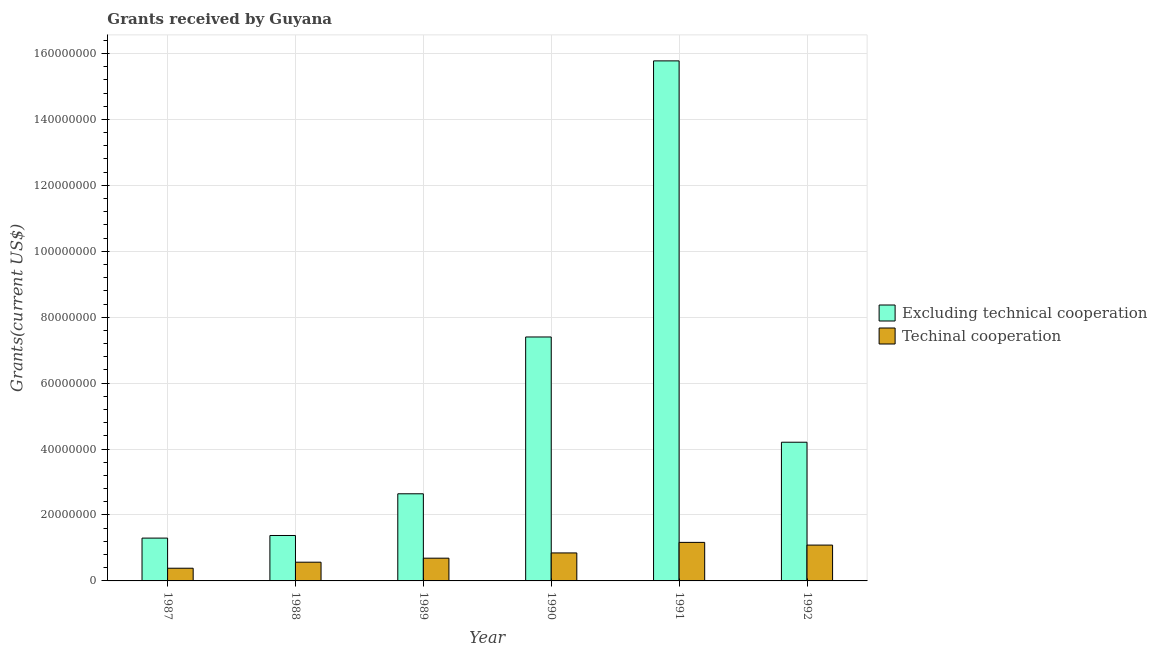How many different coloured bars are there?
Your response must be concise. 2. How many groups of bars are there?
Ensure brevity in your answer.  6. Are the number of bars per tick equal to the number of legend labels?
Offer a terse response. Yes. Are the number of bars on each tick of the X-axis equal?
Give a very brief answer. Yes. In how many cases, is the number of bars for a given year not equal to the number of legend labels?
Ensure brevity in your answer.  0. What is the amount of grants received(excluding technical cooperation) in 1992?
Provide a succinct answer. 4.21e+07. Across all years, what is the maximum amount of grants received(excluding technical cooperation)?
Offer a very short reply. 1.58e+08. Across all years, what is the minimum amount of grants received(excluding technical cooperation)?
Your answer should be compact. 1.30e+07. In which year was the amount of grants received(including technical cooperation) maximum?
Keep it short and to the point. 1991. What is the total amount of grants received(including technical cooperation) in the graph?
Ensure brevity in your answer.  4.75e+07. What is the difference between the amount of grants received(excluding technical cooperation) in 1987 and that in 1990?
Keep it short and to the point. -6.10e+07. What is the difference between the amount of grants received(excluding technical cooperation) in 1990 and the amount of grants received(including technical cooperation) in 1988?
Offer a terse response. 6.02e+07. What is the average amount of grants received(including technical cooperation) per year?
Make the answer very short. 7.91e+06. What is the ratio of the amount of grants received(including technical cooperation) in 1987 to that in 1990?
Your answer should be compact. 0.45. Is the amount of grants received(excluding technical cooperation) in 1988 less than that in 1992?
Keep it short and to the point. Yes. Is the difference between the amount of grants received(excluding technical cooperation) in 1987 and 1991 greater than the difference between the amount of grants received(including technical cooperation) in 1987 and 1991?
Offer a terse response. No. What is the difference between the highest and the second highest amount of grants received(including technical cooperation)?
Your answer should be compact. 8.20e+05. What is the difference between the highest and the lowest amount of grants received(including technical cooperation)?
Your answer should be compact. 7.84e+06. In how many years, is the amount of grants received(excluding technical cooperation) greater than the average amount of grants received(excluding technical cooperation) taken over all years?
Your answer should be compact. 2. Is the sum of the amount of grants received(excluding technical cooperation) in 1990 and 1992 greater than the maximum amount of grants received(including technical cooperation) across all years?
Make the answer very short. No. What does the 1st bar from the left in 1988 represents?
Your answer should be compact. Excluding technical cooperation. What does the 1st bar from the right in 1988 represents?
Provide a short and direct response. Techinal cooperation. Are all the bars in the graph horizontal?
Give a very brief answer. No. What is the difference between two consecutive major ticks on the Y-axis?
Offer a terse response. 2.00e+07. How many legend labels are there?
Ensure brevity in your answer.  2. What is the title of the graph?
Ensure brevity in your answer.  Grants received by Guyana. What is the label or title of the X-axis?
Offer a terse response. Year. What is the label or title of the Y-axis?
Keep it short and to the point. Grants(current US$). What is the Grants(current US$) in Excluding technical cooperation in 1987?
Offer a very short reply. 1.30e+07. What is the Grants(current US$) in Techinal cooperation in 1987?
Keep it short and to the point. 3.85e+06. What is the Grants(current US$) of Excluding technical cooperation in 1988?
Your answer should be compact. 1.38e+07. What is the Grants(current US$) of Techinal cooperation in 1988?
Make the answer very short. 5.68e+06. What is the Grants(current US$) of Excluding technical cooperation in 1989?
Your response must be concise. 2.64e+07. What is the Grants(current US$) in Techinal cooperation in 1989?
Keep it short and to the point. 6.90e+06. What is the Grants(current US$) of Excluding technical cooperation in 1990?
Provide a succinct answer. 7.40e+07. What is the Grants(current US$) in Techinal cooperation in 1990?
Provide a succinct answer. 8.49e+06. What is the Grants(current US$) in Excluding technical cooperation in 1991?
Your answer should be compact. 1.58e+08. What is the Grants(current US$) in Techinal cooperation in 1991?
Your answer should be very brief. 1.17e+07. What is the Grants(current US$) in Excluding technical cooperation in 1992?
Your answer should be very brief. 4.21e+07. What is the Grants(current US$) in Techinal cooperation in 1992?
Your answer should be very brief. 1.09e+07. Across all years, what is the maximum Grants(current US$) in Excluding technical cooperation?
Make the answer very short. 1.58e+08. Across all years, what is the maximum Grants(current US$) of Techinal cooperation?
Provide a succinct answer. 1.17e+07. Across all years, what is the minimum Grants(current US$) in Excluding technical cooperation?
Offer a very short reply. 1.30e+07. Across all years, what is the minimum Grants(current US$) of Techinal cooperation?
Ensure brevity in your answer.  3.85e+06. What is the total Grants(current US$) of Excluding technical cooperation in the graph?
Provide a short and direct response. 3.27e+08. What is the total Grants(current US$) in Techinal cooperation in the graph?
Provide a succinct answer. 4.75e+07. What is the difference between the Grants(current US$) of Excluding technical cooperation in 1987 and that in 1988?
Ensure brevity in your answer.  -7.90e+05. What is the difference between the Grants(current US$) of Techinal cooperation in 1987 and that in 1988?
Make the answer very short. -1.83e+06. What is the difference between the Grants(current US$) in Excluding technical cooperation in 1987 and that in 1989?
Your response must be concise. -1.34e+07. What is the difference between the Grants(current US$) in Techinal cooperation in 1987 and that in 1989?
Give a very brief answer. -3.05e+06. What is the difference between the Grants(current US$) of Excluding technical cooperation in 1987 and that in 1990?
Offer a terse response. -6.10e+07. What is the difference between the Grants(current US$) of Techinal cooperation in 1987 and that in 1990?
Ensure brevity in your answer.  -4.64e+06. What is the difference between the Grants(current US$) of Excluding technical cooperation in 1987 and that in 1991?
Ensure brevity in your answer.  -1.45e+08. What is the difference between the Grants(current US$) in Techinal cooperation in 1987 and that in 1991?
Offer a terse response. -7.84e+06. What is the difference between the Grants(current US$) in Excluding technical cooperation in 1987 and that in 1992?
Provide a short and direct response. -2.91e+07. What is the difference between the Grants(current US$) of Techinal cooperation in 1987 and that in 1992?
Your response must be concise. -7.02e+06. What is the difference between the Grants(current US$) of Excluding technical cooperation in 1988 and that in 1989?
Provide a succinct answer. -1.26e+07. What is the difference between the Grants(current US$) of Techinal cooperation in 1988 and that in 1989?
Offer a terse response. -1.22e+06. What is the difference between the Grants(current US$) of Excluding technical cooperation in 1988 and that in 1990?
Make the answer very short. -6.02e+07. What is the difference between the Grants(current US$) in Techinal cooperation in 1988 and that in 1990?
Provide a succinct answer. -2.81e+06. What is the difference between the Grants(current US$) in Excluding technical cooperation in 1988 and that in 1991?
Give a very brief answer. -1.44e+08. What is the difference between the Grants(current US$) of Techinal cooperation in 1988 and that in 1991?
Provide a short and direct response. -6.01e+06. What is the difference between the Grants(current US$) of Excluding technical cooperation in 1988 and that in 1992?
Your answer should be very brief. -2.83e+07. What is the difference between the Grants(current US$) in Techinal cooperation in 1988 and that in 1992?
Offer a terse response. -5.19e+06. What is the difference between the Grants(current US$) of Excluding technical cooperation in 1989 and that in 1990?
Keep it short and to the point. -4.76e+07. What is the difference between the Grants(current US$) in Techinal cooperation in 1989 and that in 1990?
Give a very brief answer. -1.59e+06. What is the difference between the Grants(current US$) of Excluding technical cooperation in 1989 and that in 1991?
Your answer should be very brief. -1.31e+08. What is the difference between the Grants(current US$) in Techinal cooperation in 1989 and that in 1991?
Your answer should be very brief. -4.79e+06. What is the difference between the Grants(current US$) in Excluding technical cooperation in 1989 and that in 1992?
Your answer should be very brief. -1.56e+07. What is the difference between the Grants(current US$) of Techinal cooperation in 1989 and that in 1992?
Give a very brief answer. -3.97e+06. What is the difference between the Grants(current US$) of Excluding technical cooperation in 1990 and that in 1991?
Provide a short and direct response. -8.38e+07. What is the difference between the Grants(current US$) of Techinal cooperation in 1990 and that in 1991?
Provide a short and direct response. -3.20e+06. What is the difference between the Grants(current US$) of Excluding technical cooperation in 1990 and that in 1992?
Provide a succinct answer. 3.19e+07. What is the difference between the Grants(current US$) of Techinal cooperation in 1990 and that in 1992?
Your response must be concise. -2.38e+06. What is the difference between the Grants(current US$) of Excluding technical cooperation in 1991 and that in 1992?
Offer a terse response. 1.16e+08. What is the difference between the Grants(current US$) of Techinal cooperation in 1991 and that in 1992?
Your answer should be compact. 8.20e+05. What is the difference between the Grants(current US$) of Excluding technical cooperation in 1987 and the Grants(current US$) of Techinal cooperation in 1988?
Keep it short and to the point. 7.31e+06. What is the difference between the Grants(current US$) of Excluding technical cooperation in 1987 and the Grants(current US$) of Techinal cooperation in 1989?
Your response must be concise. 6.09e+06. What is the difference between the Grants(current US$) in Excluding technical cooperation in 1987 and the Grants(current US$) in Techinal cooperation in 1990?
Give a very brief answer. 4.50e+06. What is the difference between the Grants(current US$) in Excluding technical cooperation in 1987 and the Grants(current US$) in Techinal cooperation in 1991?
Offer a terse response. 1.30e+06. What is the difference between the Grants(current US$) of Excluding technical cooperation in 1987 and the Grants(current US$) of Techinal cooperation in 1992?
Offer a terse response. 2.12e+06. What is the difference between the Grants(current US$) of Excluding technical cooperation in 1988 and the Grants(current US$) of Techinal cooperation in 1989?
Your answer should be compact. 6.88e+06. What is the difference between the Grants(current US$) of Excluding technical cooperation in 1988 and the Grants(current US$) of Techinal cooperation in 1990?
Your response must be concise. 5.29e+06. What is the difference between the Grants(current US$) in Excluding technical cooperation in 1988 and the Grants(current US$) in Techinal cooperation in 1991?
Keep it short and to the point. 2.09e+06. What is the difference between the Grants(current US$) in Excluding technical cooperation in 1988 and the Grants(current US$) in Techinal cooperation in 1992?
Your answer should be compact. 2.91e+06. What is the difference between the Grants(current US$) in Excluding technical cooperation in 1989 and the Grants(current US$) in Techinal cooperation in 1990?
Provide a short and direct response. 1.79e+07. What is the difference between the Grants(current US$) in Excluding technical cooperation in 1989 and the Grants(current US$) in Techinal cooperation in 1991?
Give a very brief answer. 1.47e+07. What is the difference between the Grants(current US$) in Excluding technical cooperation in 1989 and the Grants(current US$) in Techinal cooperation in 1992?
Your response must be concise. 1.56e+07. What is the difference between the Grants(current US$) of Excluding technical cooperation in 1990 and the Grants(current US$) of Techinal cooperation in 1991?
Your response must be concise. 6.23e+07. What is the difference between the Grants(current US$) of Excluding technical cooperation in 1990 and the Grants(current US$) of Techinal cooperation in 1992?
Ensure brevity in your answer.  6.31e+07. What is the difference between the Grants(current US$) in Excluding technical cooperation in 1991 and the Grants(current US$) in Techinal cooperation in 1992?
Offer a terse response. 1.47e+08. What is the average Grants(current US$) in Excluding technical cooperation per year?
Give a very brief answer. 5.45e+07. What is the average Grants(current US$) of Techinal cooperation per year?
Give a very brief answer. 7.91e+06. In the year 1987, what is the difference between the Grants(current US$) of Excluding technical cooperation and Grants(current US$) of Techinal cooperation?
Offer a very short reply. 9.14e+06. In the year 1988, what is the difference between the Grants(current US$) in Excluding technical cooperation and Grants(current US$) in Techinal cooperation?
Provide a succinct answer. 8.10e+06. In the year 1989, what is the difference between the Grants(current US$) in Excluding technical cooperation and Grants(current US$) in Techinal cooperation?
Offer a terse response. 1.95e+07. In the year 1990, what is the difference between the Grants(current US$) in Excluding technical cooperation and Grants(current US$) in Techinal cooperation?
Your answer should be very brief. 6.55e+07. In the year 1991, what is the difference between the Grants(current US$) of Excluding technical cooperation and Grants(current US$) of Techinal cooperation?
Ensure brevity in your answer.  1.46e+08. In the year 1992, what is the difference between the Grants(current US$) in Excluding technical cooperation and Grants(current US$) in Techinal cooperation?
Provide a short and direct response. 3.12e+07. What is the ratio of the Grants(current US$) in Excluding technical cooperation in 1987 to that in 1988?
Your answer should be compact. 0.94. What is the ratio of the Grants(current US$) of Techinal cooperation in 1987 to that in 1988?
Your answer should be compact. 0.68. What is the ratio of the Grants(current US$) of Excluding technical cooperation in 1987 to that in 1989?
Your answer should be very brief. 0.49. What is the ratio of the Grants(current US$) of Techinal cooperation in 1987 to that in 1989?
Ensure brevity in your answer.  0.56. What is the ratio of the Grants(current US$) in Excluding technical cooperation in 1987 to that in 1990?
Offer a terse response. 0.18. What is the ratio of the Grants(current US$) in Techinal cooperation in 1987 to that in 1990?
Provide a succinct answer. 0.45. What is the ratio of the Grants(current US$) of Excluding technical cooperation in 1987 to that in 1991?
Provide a short and direct response. 0.08. What is the ratio of the Grants(current US$) of Techinal cooperation in 1987 to that in 1991?
Provide a succinct answer. 0.33. What is the ratio of the Grants(current US$) of Excluding technical cooperation in 1987 to that in 1992?
Provide a succinct answer. 0.31. What is the ratio of the Grants(current US$) in Techinal cooperation in 1987 to that in 1992?
Offer a terse response. 0.35. What is the ratio of the Grants(current US$) of Excluding technical cooperation in 1988 to that in 1989?
Your answer should be compact. 0.52. What is the ratio of the Grants(current US$) in Techinal cooperation in 1988 to that in 1989?
Make the answer very short. 0.82. What is the ratio of the Grants(current US$) of Excluding technical cooperation in 1988 to that in 1990?
Make the answer very short. 0.19. What is the ratio of the Grants(current US$) in Techinal cooperation in 1988 to that in 1990?
Give a very brief answer. 0.67. What is the ratio of the Grants(current US$) of Excluding technical cooperation in 1988 to that in 1991?
Your answer should be very brief. 0.09. What is the ratio of the Grants(current US$) of Techinal cooperation in 1988 to that in 1991?
Your response must be concise. 0.49. What is the ratio of the Grants(current US$) in Excluding technical cooperation in 1988 to that in 1992?
Your response must be concise. 0.33. What is the ratio of the Grants(current US$) in Techinal cooperation in 1988 to that in 1992?
Make the answer very short. 0.52. What is the ratio of the Grants(current US$) in Excluding technical cooperation in 1989 to that in 1990?
Offer a terse response. 0.36. What is the ratio of the Grants(current US$) in Techinal cooperation in 1989 to that in 1990?
Offer a terse response. 0.81. What is the ratio of the Grants(current US$) in Excluding technical cooperation in 1989 to that in 1991?
Give a very brief answer. 0.17. What is the ratio of the Grants(current US$) in Techinal cooperation in 1989 to that in 1991?
Your response must be concise. 0.59. What is the ratio of the Grants(current US$) in Excluding technical cooperation in 1989 to that in 1992?
Keep it short and to the point. 0.63. What is the ratio of the Grants(current US$) of Techinal cooperation in 1989 to that in 1992?
Provide a succinct answer. 0.63. What is the ratio of the Grants(current US$) in Excluding technical cooperation in 1990 to that in 1991?
Make the answer very short. 0.47. What is the ratio of the Grants(current US$) in Techinal cooperation in 1990 to that in 1991?
Keep it short and to the point. 0.73. What is the ratio of the Grants(current US$) of Excluding technical cooperation in 1990 to that in 1992?
Your answer should be compact. 1.76. What is the ratio of the Grants(current US$) in Techinal cooperation in 1990 to that in 1992?
Your answer should be compact. 0.78. What is the ratio of the Grants(current US$) in Excluding technical cooperation in 1991 to that in 1992?
Offer a very short reply. 3.75. What is the ratio of the Grants(current US$) of Techinal cooperation in 1991 to that in 1992?
Your response must be concise. 1.08. What is the difference between the highest and the second highest Grants(current US$) of Excluding technical cooperation?
Provide a short and direct response. 8.38e+07. What is the difference between the highest and the second highest Grants(current US$) in Techinal cooperation?
Your answer should be very brief. 8.20e+05. What is the difference between the highest and the lowest Grants(current US$) of Excluding technical cooperation?
Provide a short and direct response. 1.45e+08. What is the difference between the highest and the lowest Grants(current US$) in Techinal cooperation?
Offer a terse response. 7.84e+06. 